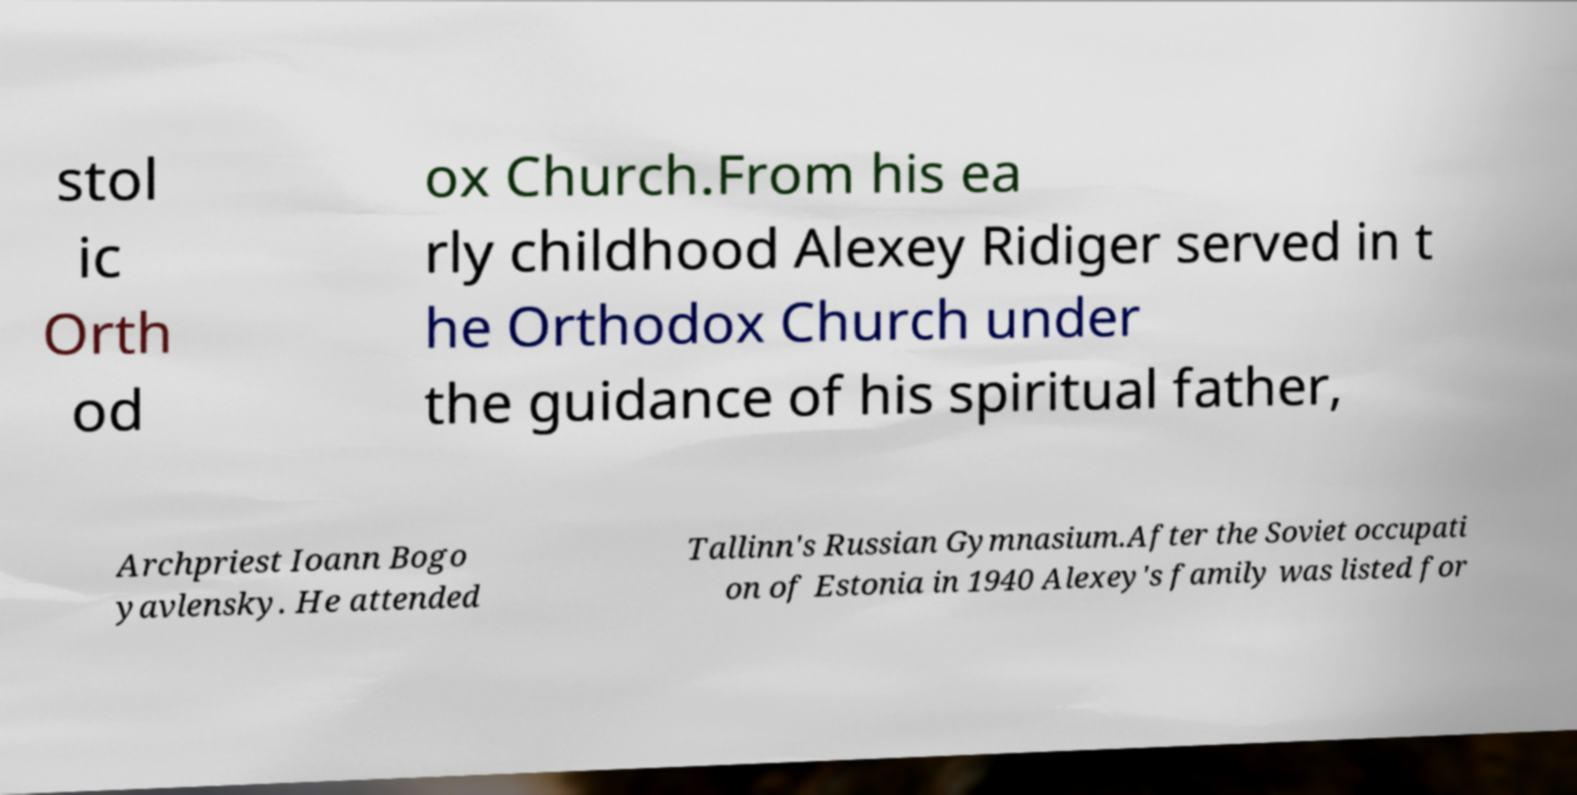Can you accurately transcribe the text from the provided image for me? stol ic Orth od ox Church.From his ea rly childhood Alexey Ridiger served in t he Orthodox Church under the guidance of his spiritual father, Archpriest Ioann Bogo yavlensky. He attended Tallinn's Russian Gymnasium.After the Soviet occupati on of Estonia in 1940 Alexey's family was listed for 